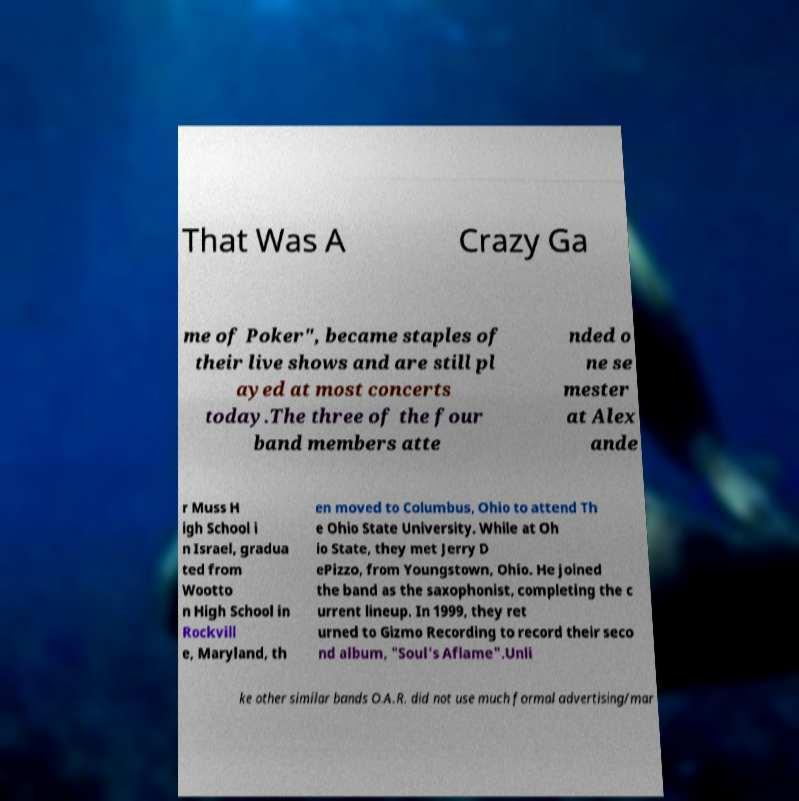Please read and relay the text visible in this image. What does it say? That Was A Crazy Ga me of Poker", became staples of their live shows and are still pl ayed at most concerts today.The three of the four band members atte nded o ne se mester at Alex ande r Muss H igh School i n Israel, gradua ted from Wootto n High School in Rockvill e, Maryland, th en moved to Columbus, Ohio to attend Th e Ohio State University. While at Oh io State, they met Jerry D ePizzo, from Youngstown, Ohio. He joined the band as the saxophonist, completing the c urrent lineup. In 1999, they ret urned to Gizmo Recording to record their seco nd album, "Soul's Aflame".Unli ke other similar bands O.A.R. did not use much formal advertising/mar 